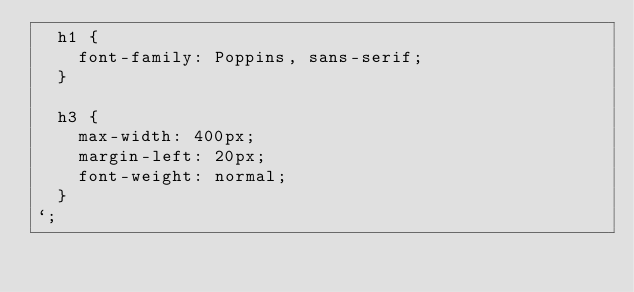Convert code to text. <code><loc_0><loc_0><loc_500><loc_500><_JavaScript_>  h1 {
    font-family: Poppins, sans-serif;
  }

  h3 {
    max-width: 400px;
    margin-left: 20px;
    font-weight: normal;
  }
`;
</code> 